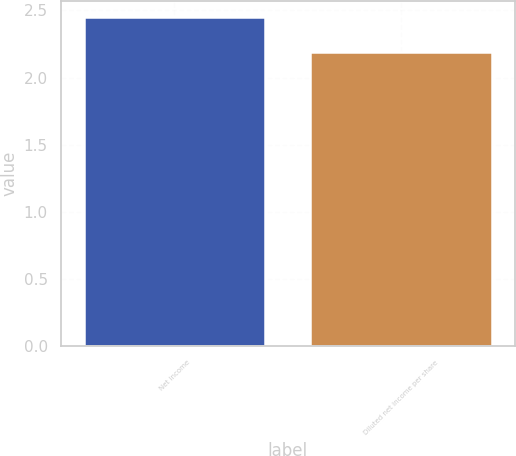<chart> <loc_0><loc_0><loc_500><loc_500><bar_chart><fcel>Net income<fcel>Diluted net income per share<nl><fcel>2.45<fcel>2.19<nl></chart> 